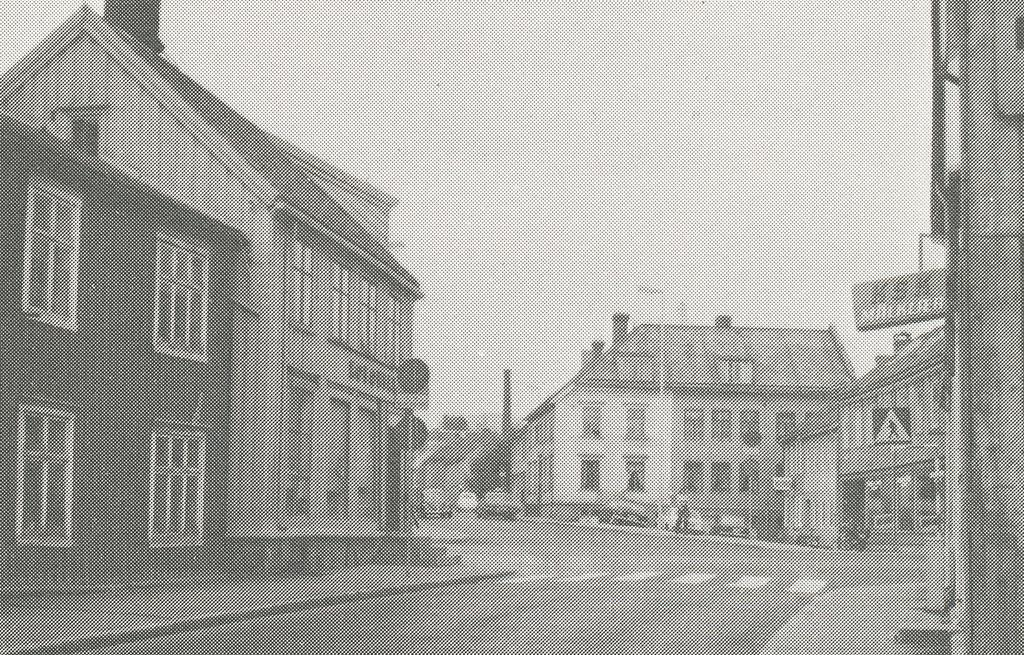<image>
Share a concise interpretation of the image provided. An old road with a sign that reads KSK on one of the buildings on the right. 